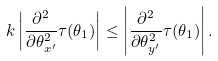Convert formula to latex. <formula><loc_0><loc_0><loc_500><loc_500>k \left | \frac { \partial ^ { 2 } } { \partial \theta _ { x ^ { \prime } } ^ { 2 } } \tau ( \theta _ { 1 } ) \right | \leq \left | \frac { \partial ^ { 2 } } { \partial \theta _ { y ^ { \prime } } ^ { 2 } } \tau ( \theta _ { 1 } ) \right | .</formula> 